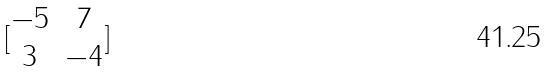Convert formula to latex. <formula><loc_0><loc_0><loc_500><loc_500>[ \begin{matrix} - 5 & 7 \\ 3 & - 4 \end{matrix} ]</formula> 